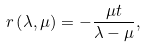<formula> <loc_0><loc_0><loc_500><loc_500>r \left ( \lambda , \mu \right ) = - \frac { \mu t } { \lambda - \mu } ,</formula> 